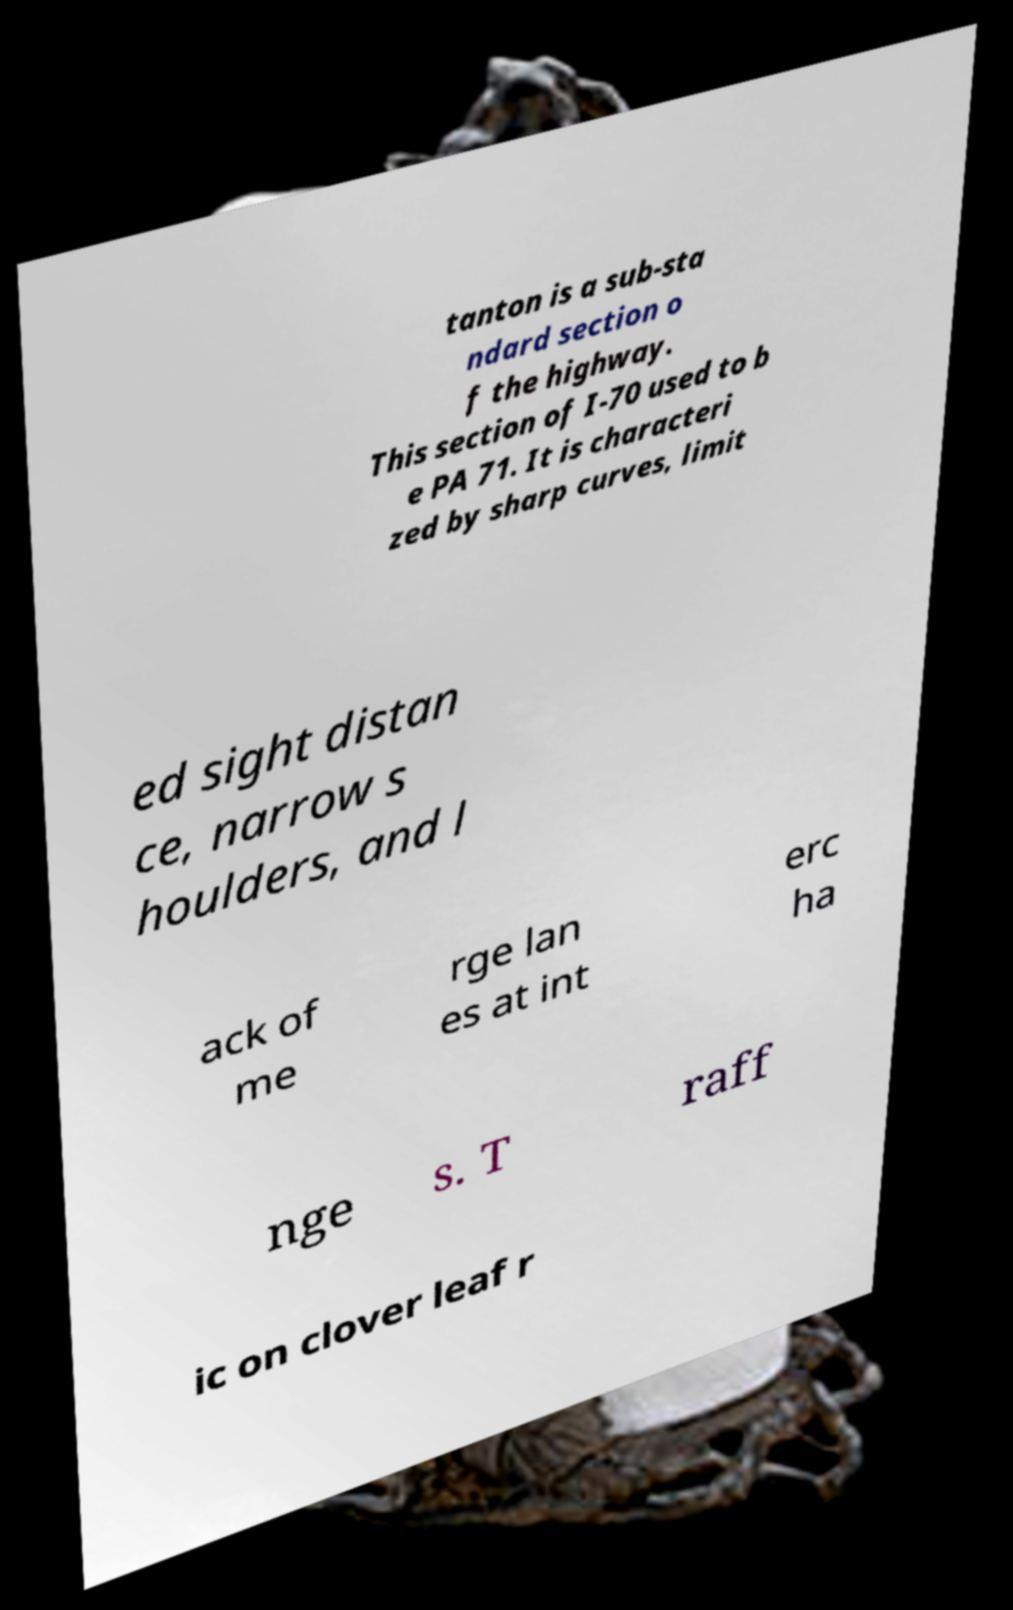Could you extract and type out the text from this image? tanton is a sub-sta ndard section o f the highway. This section of I-70 used to b e PA 71. It is characteri zed by sharp curves, limit ed sight distan ce, narrow s houlders, and l ack of me rge lan es at int erc ha nge s. T raff ic on clover leaf r 